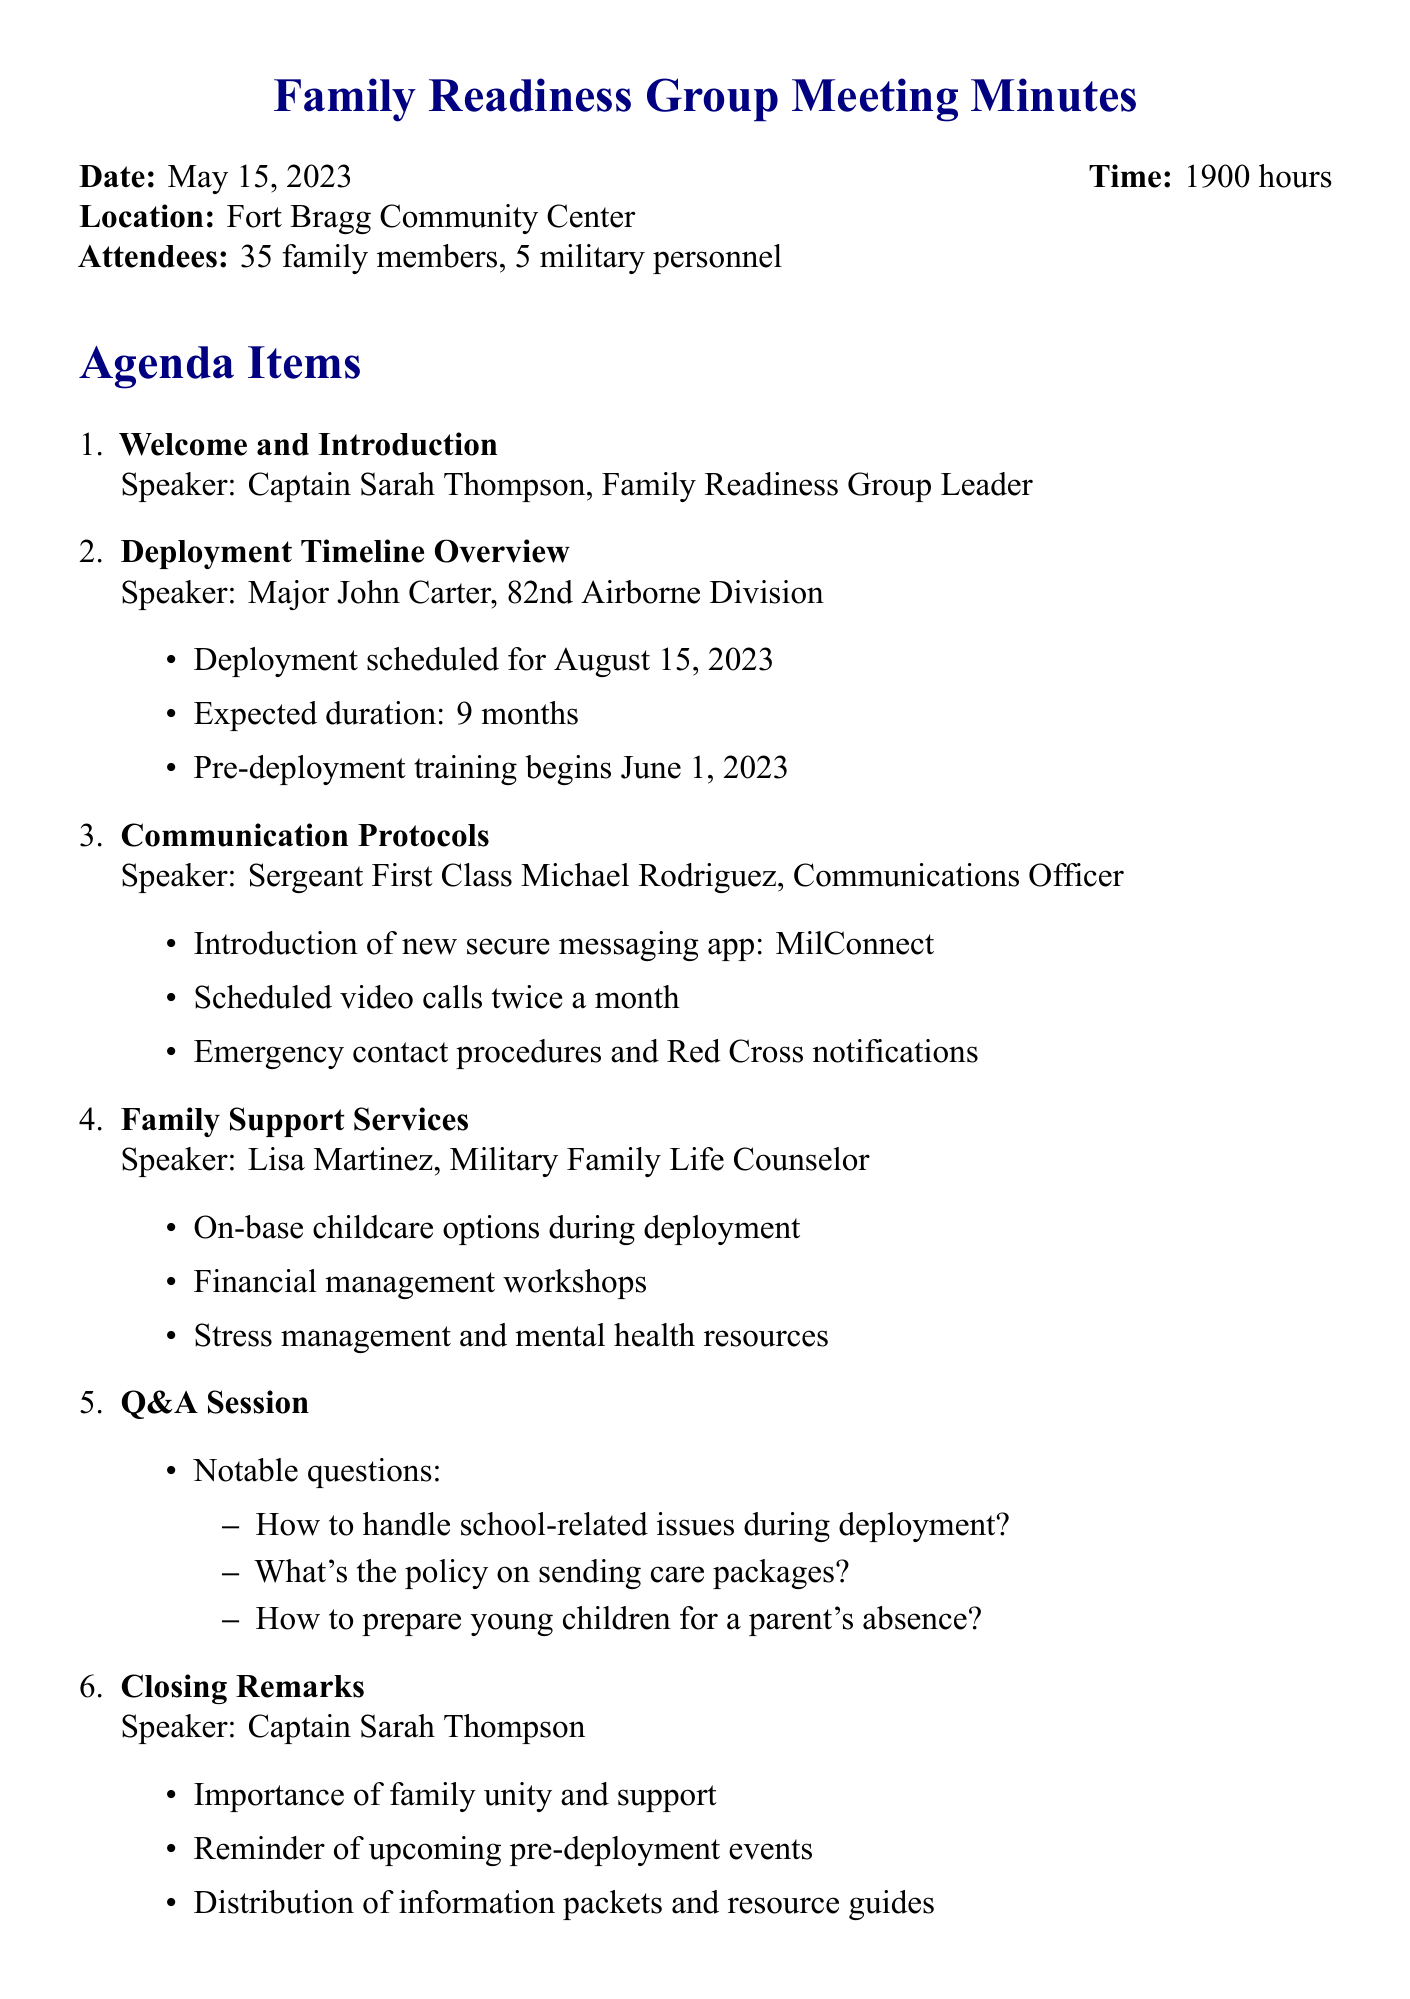What is the date of the meeting? The date of the meeting is specified at the beginning of the document.
Answer: May 15, 2023 Who is the speaker for the Deployment Timeline Overview? This information is found under the agenda item for Deployment Timeline Overview.
Answer: Major John Carter, 82nd Airborne Division When does pre-deployment training begin? The start date for pre-deployment training is outlined in the meeting agenda.
Answer: June 1, 2023 How long is the expected duration of the deployment? The expected duration is stated in the Deployment Timeline Overview section.
Answer: 9 months What new communication app was introduced? This detail is found in the Communication Protocols section of the document.
Answer: MilConnect What action item is due by June 1, 2023? Information about action items is outlined in the Action Items section.
Answer: Families to complete emergency contact forms How many family members attended the meeting? The number of attendees is listed at the start of the minutes.
Answer: 35 family members What are the scheduled video calls frequency? This frequency is specified in the Communication Protocols portion of the document.
Answer: Twice a month What was the main focus during the Q&A session? The notable questions during the Q&A session reflect the family concerns discussed.
Answer: School-related issues, care package policy, preparing young children for absence 